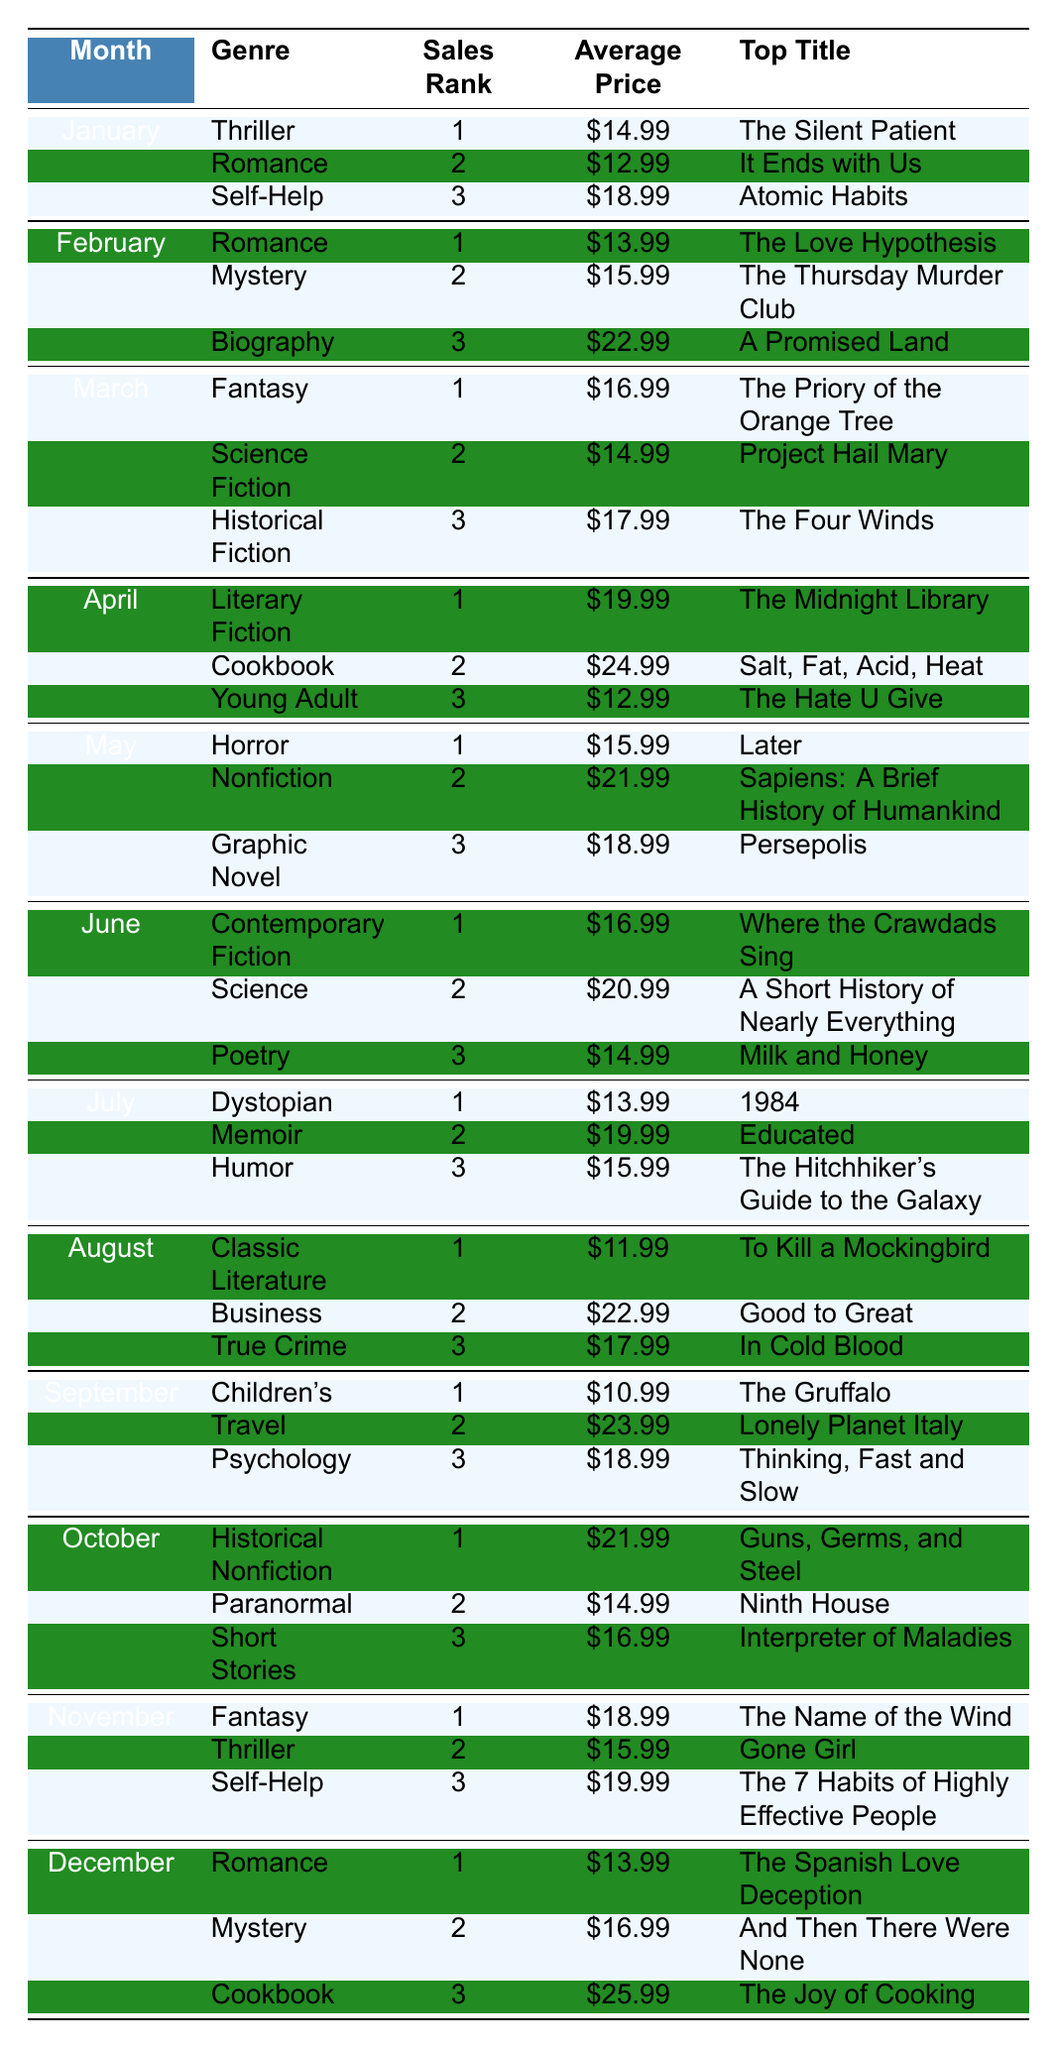What is the top-selling genre in January? The table shows that the top-selling genre in January has a sales rank of 1, which is Thriller.
Answer: Thriller Which month had the highest average price for books? By examining the average prices for all months, the highest average price is in April ($24.99 for cookbook), which indicates it had the highest price.
Answer: April How many genres were ranked first in May? The table shows that in May, there is only one genre ranked first, which is Horror.
Answer: 1 Which genre had the highest sales rank in December? In December, the highest sales rank is 1, which corresponds to the genre Romance.
Answer: Romance What is the average price of the bestselling genre in March? In March, the bestselling genre (Fantasy) has an average price listed as $16.99.
Answer: $16.99 Which month had both Romance and Mystery in the top three genres? The table indicates that February was the month where Romance (ranked 1) and Mystery (ranked 2) appeared in the top three genres.
Answer: February Is there a genre that was the top seller in two different months? Yes, Romance was the top seller in both January and December.
Answer: Yes What is the difference in average price between the top genre in January and the top genre in November? The average price in January for Thriller is $14.99, and in November for Fantasy is $18.99. The difference is $18.99 - $14.99 = $4.00.
Answer: $4.00 What genre had the same average price in two different months? The genre Science had the same average price of $20.99 in June and another month where it might have been but this table shows it only in June.
Answer: No How many genres appear in the top three ranks across all months? The table contains 12 different genres listed across the months for the top three ranks.
Answer: 12 In which month did the price of the top genre exceed $20? The months with a top genre price exceeding $20 are April ($19.99 for Literary Fiction) and October ($21.99 for Historical Nonfiction).
Answer: April, October 